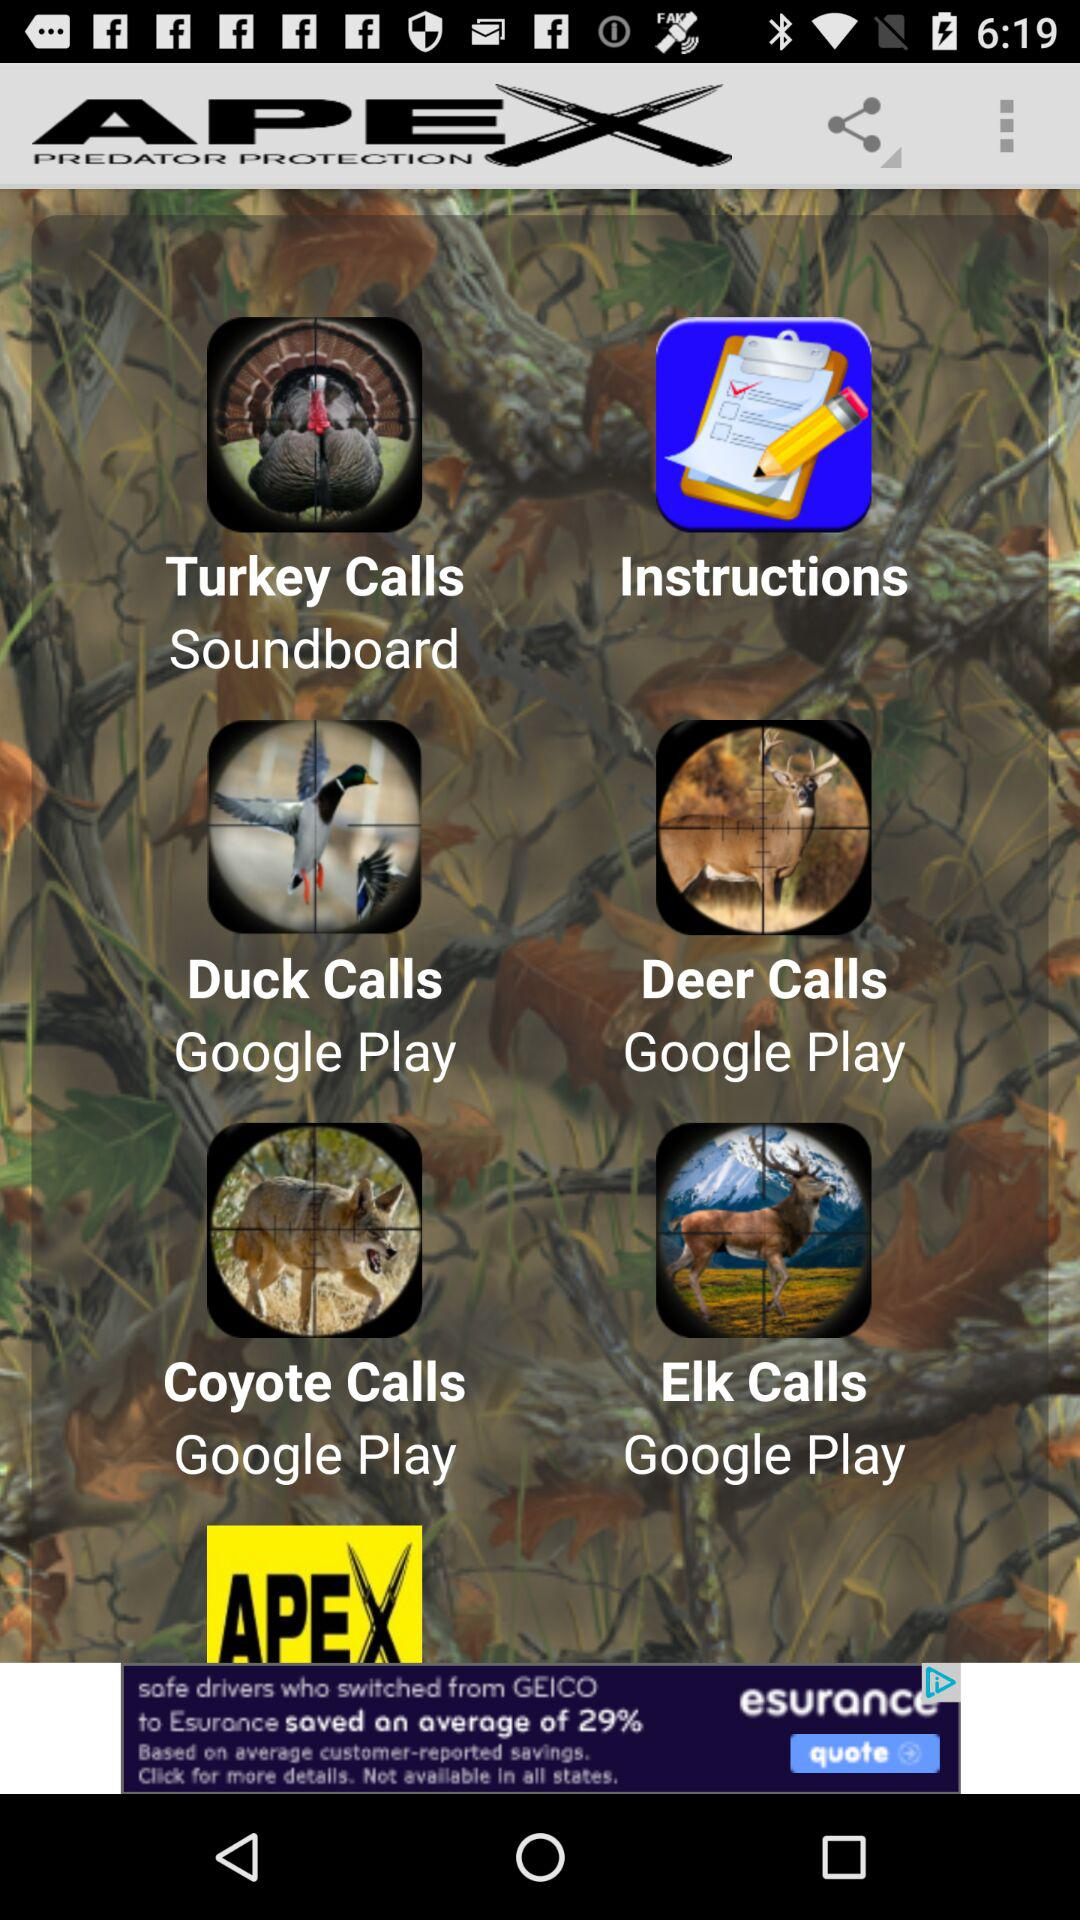What is the name of the application? The name of the application is "APEX PREDATOR PROTECTION". 